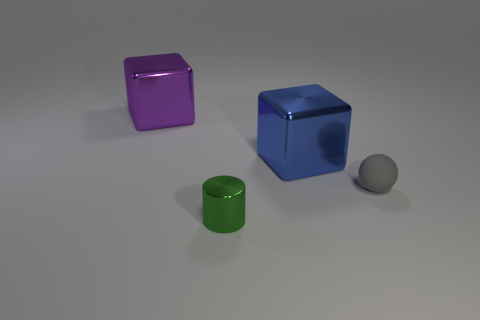Is there any other thing that has the same shape as the rubber object?
Provide a short and direct response. No. Are there any blue objects that have the same size as the green metal cylinder?
Your answer should be very brief. No. Do the small green thing and the sphere have the same material?
Ensure brevity in your answer.  No. How many objects are either large cyan metallic objects or small balls?
Offer a terse response. 1. The blue thing is what size?
Your response must be concise. Large. Is the number of large cubes less than the number of purple things?
Your answer should be very brief. No. Does the tiny thing on the left side of the sphere have the same color as the rubber object?
Your response must be concise. No. There is a large object that is to the right of the big purple metallic object; what is its shape?
Provide a short and direct response. Cube. Are there any cubes that are in front of the big shiny cube on the left side of the green shiny object?
Offer a terse response. Yes. What number of purple objects have the same material as the green cylinder?
Offer a terse response. 1. 